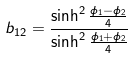<formula> <loc_0><loc_0><loc_500><loc_500>b _ { 1 2 } = \frac { \sinh ^ { 2 } \frac { \phi _ { 1 } - \phi _ { 2 } } { 4 } } { \sinh ^ { 2 } \frac { \phi _ { 1 } + \phi _ { 2 } } { 4 } }</formula> 